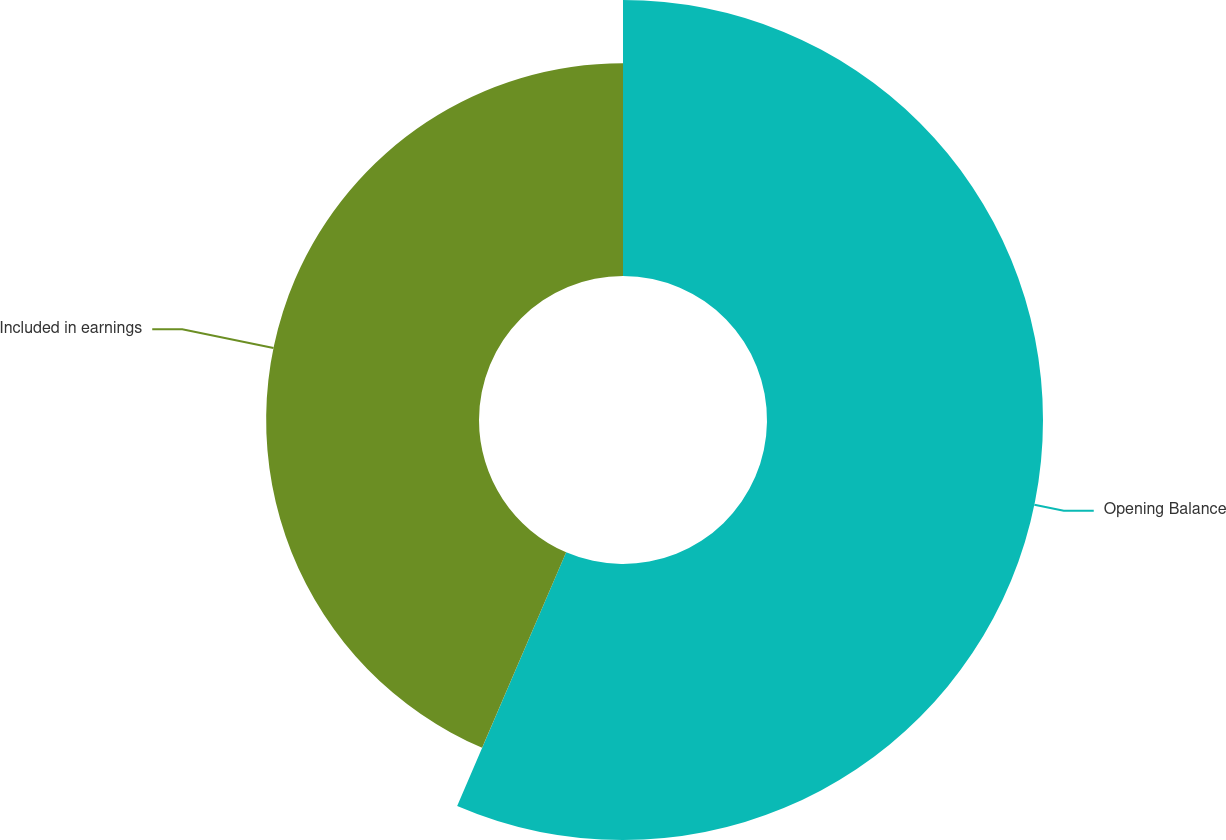Convert chart. <chart><loc_0><loc_0><loc_500><loc_500><pie_chart><fcel>Opening Balance<fcel>Included in earnings<nl><fcel>56.46%<fcel>43.54%<nl></chart> 